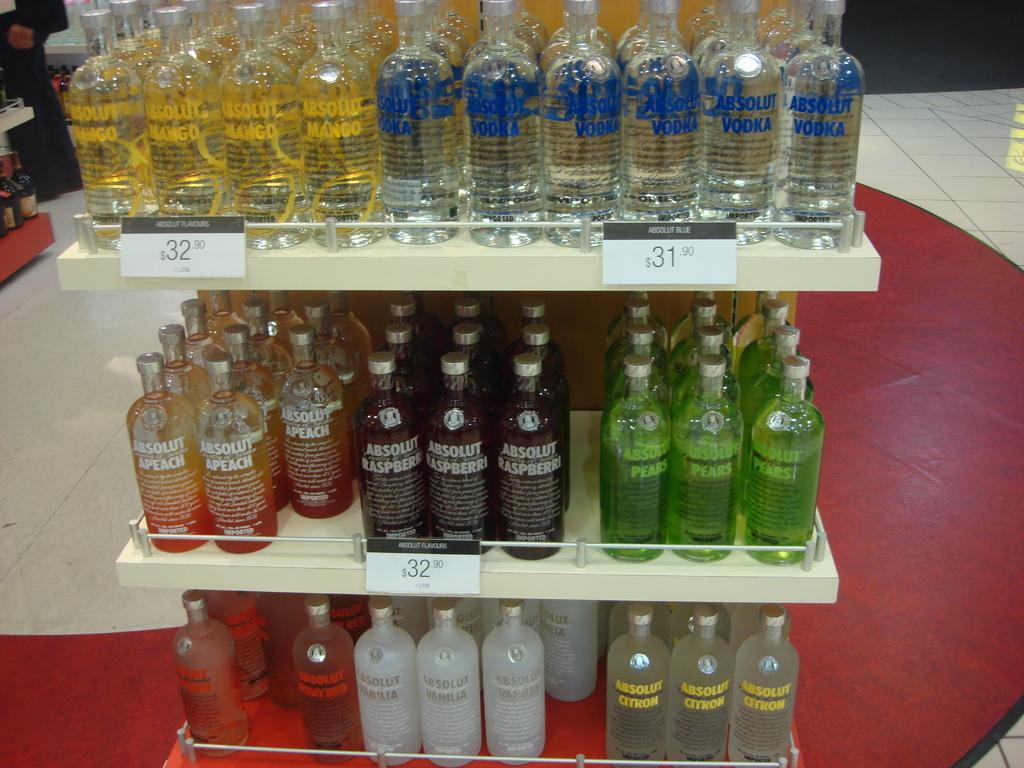<image>
Describe the image concisely. Different flavors of Absolute Vodka are lined up on three shelves. 